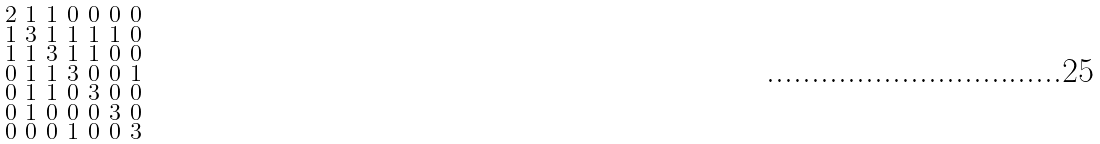<formula> <loc_0><loc_0><loc_500><loc_500>\begin{smallmatrix} 2 & 1 & 1 & 0 & 0 & 0 & 0 \\ 1 & 3 & 1 & 1 & 1 & 1 & 0 \\ 1 & 1 & 3 & 1 & 1 & 0 & 0 \\ 0 & 1 & 1 & 3 & 0 & 0 & 1 \\ 0 & 1 & 1 & 0 & 3 & 0 & 0 \\ 0 & 1 & 0 & 0 & 0 & 3 & 0 \\ 0 & 0 & 0 & 1 & 0 & 0 & 3 \end{smallmatrix}</formula> 